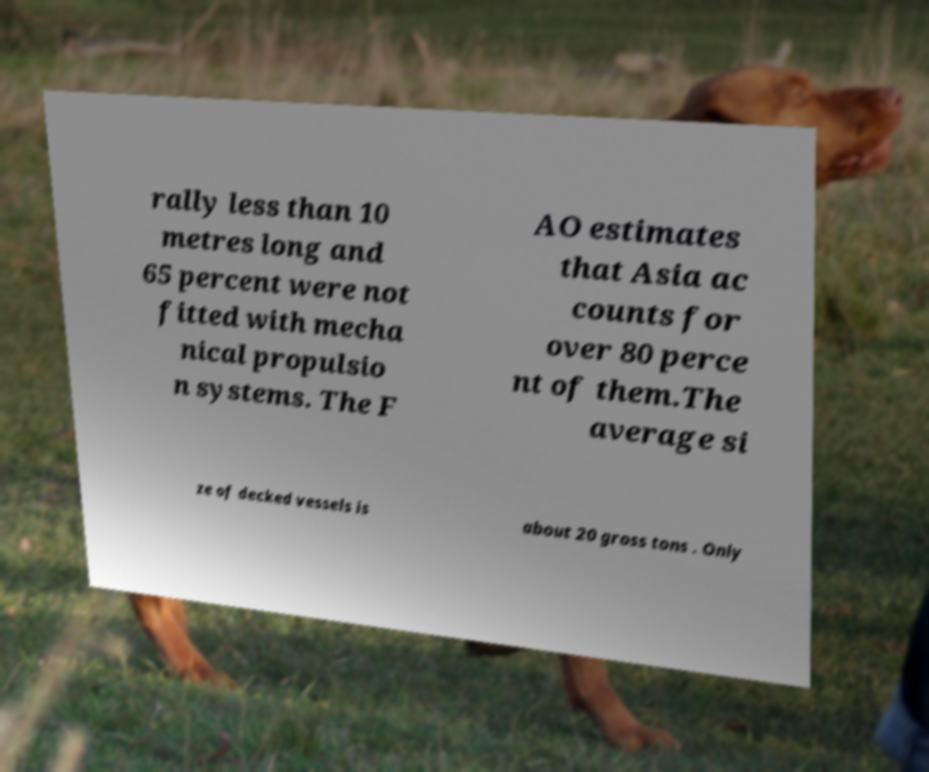Could you extract and type out the text from this image? rally less than 10 metres long and 65 percent were not fitted with mecha nical propulsio n systems. The F AO estimates that Asia ac counts for over 80 perce nt of them.The average si ze of decked vessels is about 20 gross tons . Only 